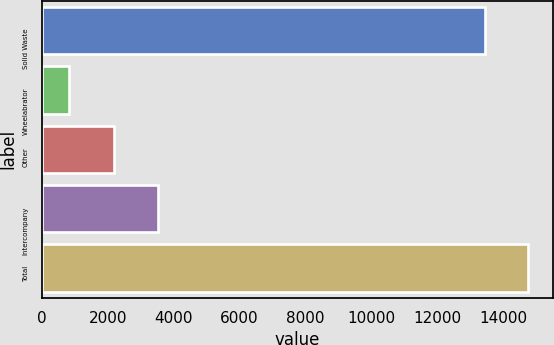Convert chart to OTSL. <chart><loc_0><loc_0><loc_500><loc_500><bar_chart><fcel>Solid Waste<fcel>Wheelabrator<fcel>Other<fcel>Intercompany<fcel>Total<nl><fcel>13449<fcel>817<fcel>2191<fcel>3508.9<fcel>14766.9<nl></chart> 